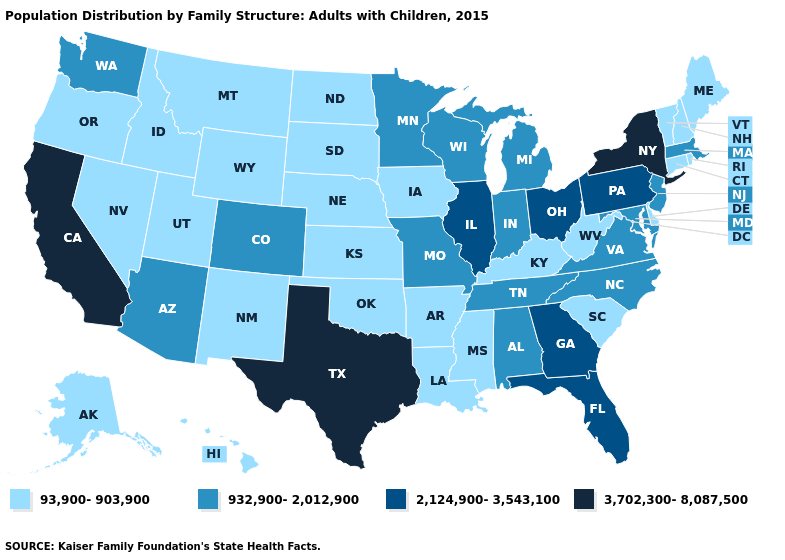Among the states that border New York , does Vermont have the lowest value?
Answer briefly. Yes. Which states have the lowest value in the USA?
Keep it brief. Alaska, Arkansas, Connecticut, Delaware, Hawaii, Idaho, Iowa, Kansas, Kentucky, Louisiana, Maine, Mississippi, Montana, Nebraska, Nevada, New Hampshire, New Mexico, North Dakota, Oklahoma, Oregon, Rhode Island, South Carolina, South Dakota, Utah, Vermont, West Virginia, Wyoming. Which states have the lowest value in the USA?
Concise answer only. Alaska, Arkansas, Connecticut, Delaware, Hawaii, Idaho, Iowa, Kansas, Kentucky, Louisiana, Maine, Mississippi, Montana, Nebraska, Nevada, New Hampshire, New Mexico, North Dakota, Oklahoma, Oregon, Rhode Island, South Carolina, South Dakota, Utah, Vermont, West Virginia, Wyoming. Among the states that border Ohio , does Pennsylvania have the lowest value?
Answer briefly. No. What is the lowest value in the South?
Answer briefly. 93,900-903,900. Name the states that have a value in the range 3,702,300-8,087,500?
Keep it brief. California, New York, Texas. Name the states that have a value in the range 3,702,300-8,087,500?
Write a very short answer. California, New York, Texas. Which states hav the highest value in the Northeast?
Answer briefly. New York. What is the highest value in the USA?
Quick response, please. 3,702,300-8,087,500. Which states have the lowest value in the USA?
Short answer required. Alaska, Arkansas, Connecticut, Delaware, Hawaii, Idaho, Iowa, Kansas, Kentucky, Louisiana, Maine, Mississippi, Montana, Nebraska, Nevada, New Hampshire, New Mexico, North Dakota, Oklahoma, Oregon, Rhode Island, South Carolina, South Dakota, Utah, Vermont, West Virginia, Wyoming. Name the states that have a value in the range 93,900-903,900?
Write a very short answer. Alaska, Arkansas, Connecticut, Delaware, Hawaii, Idaho, Iowa, Kansas, Kentucky, Louisiana, Maine, Mississippi, Montana, Nebraska, Nevada, New Hampshire, New Mexico, North Dakota, Oklahoma, Oregon, Rhode Island, South Carolina, South Dakota, Utah, Vermont, West Virginia, Wyoming. What is the lowest value in the Northeast?
Be succinct. 93,900-903,900. Which states have the highest value in the USA?
Concise answer only. California, New York, Texas. What is the value of Arkansas?
Give a very brief answer. 93,900-903,900. How many symbols are there in the legend?
Keep it brief. 4. 